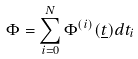Convert formula to latex. <formula><loc_0><loc_0><loc_500><loc_500>\Phi = \sum _ { i = 0 } ^ { N } \Phi ^ { ( i ) } ( \underline { t } ) d t _ { i }</formula> 